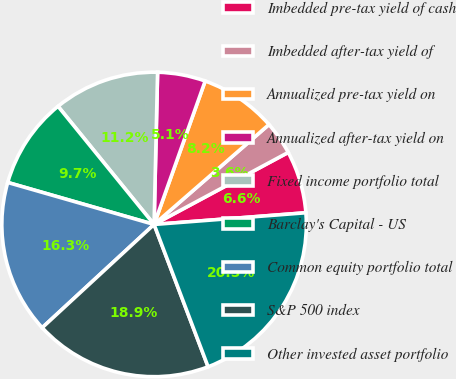Convert chart. <chart><loc_0><loc_0><loc_500><loc_500><pie_chart><fcel>Imbedded pre-tax yield of cash<fcel>Imbedded after-tax yield of<fcel>Annualized pre-tax yield on<fcel>Annualized after-tax yield on<fcel>Fixed income portfolio total<fcel>Barclay's Capital - US<fcel>Common equity portfolio total<fcel>S&P 500 index<fcel>Other invested asset portfolio<nl><fcel>6.62%<fcel>3.55%<fcel>8.16%<fcel>5.08%<fcel>11.23%<fcel>9.69%<fcel>16.31%<fcel>18.91%<fcel>20.45%<nl></chart> 